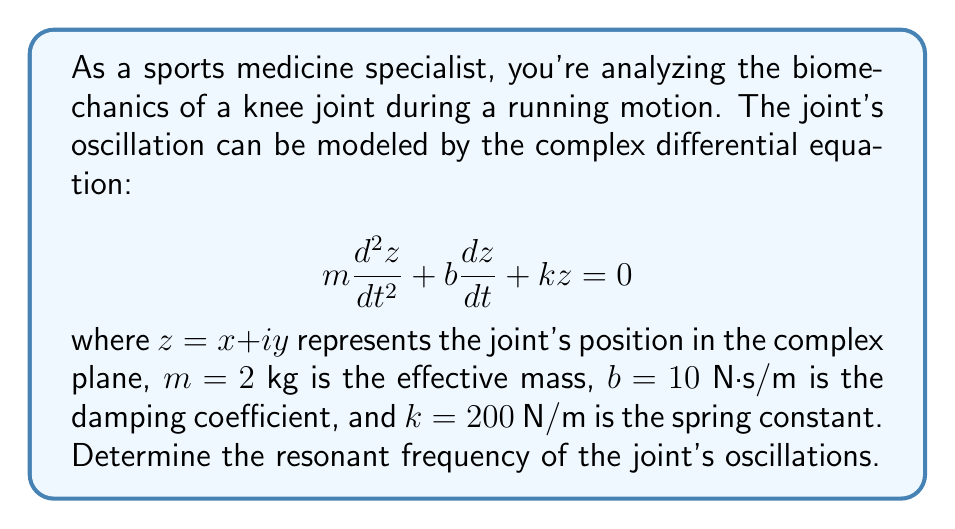Could you help me with this problem? To find the resonant frequency, we need to follow these steps:

1) The characteristic equation for this second-order differential equation is:

   $$ms^2 + bs + k = 0$$

2) Substituting the given values:

   $$2s^2 + 10s + 200 = 0$$

3) The resonant frequency is the imaginary part of the complex roots of this equation. To find the roots, we use the quadratic formula:

   $$s = \frac{-b \pm \sqrt{b^2 - 4mk}}{2m}$$

4) Substituting the values:

   $$s = \frac{-10 \pm \sqrt{10^2 - 4(2)(200)}}{2(2)}$$
   
   $$= \frac{-10 \pm \sqrt{100 - 1600}}{4}$$
   
   $$= \frac{-10 \pm \sqrt{-1500}}{4}$$
   
   $$= \frac{-10 \pm i\sqrt{1500}}{4}$$

5) Simplifying:

   $$s = -2.5 \pm i\frac{\sqrt{1500}}{4} = -2.5 \pm i9.68$$

6) The resonant frequency is the magnitude of the imaginary part:

   $$\omega_0 = 9.68 \text{ rad/s}$$

7) To convert to Hz, we divide by $2\pi$:

   $$f_0 = \frac{\omega_0}{2\pi} = \frac{9.68}{2\pi} \approx 1.54 \text{ Hz}$$
Answer: The resonant frequency of the joint's oscillations is approximately 1.54 Hz. 